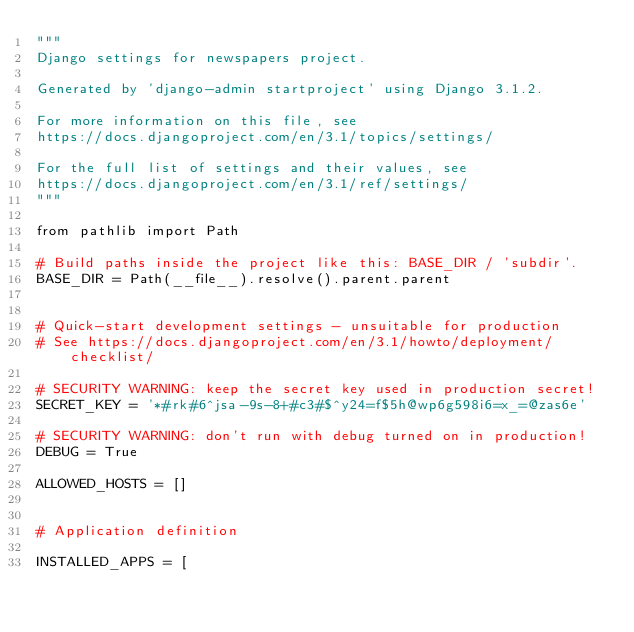Convert code to text. <code><loc_0><loc_0><loc_500><loc_500><_Python_>"""
Django settings for newspapers project.

Generated by 'django-admin startproject' using Django 3.1.2.

For more information on this file, see
https://docs.djangoproject.com/en/3.1/topics/settings/

For the full list of settings and their values, see
https://docs.djangoproject.com/en/3.1/ref/settings/
"""

from pathlib import Path

# Build paths inside the project like this: BASE_DIR / 'subdir'.
BASE_DIR = Path(__file__).resolve().parent.parent


# Quick-start development settings - unsuitable for production
# See https://docs.djangoproject.com/en/3.1/howto/deployment/checklist/

# SECURITY WARNING: keep the secret key used in production secret!
SECRET_KEY = '*#rk#6^jsa-9s-8+#c3#$^y24=f$5h@wp6g598i6=x_=@zas6e'

# SECURITY WARNING: don't run with debug turned on in production!
DEBUG = True

ALLOWED_HOSTS = []


# Application definition

INSTALLED_APPS = [</code> 